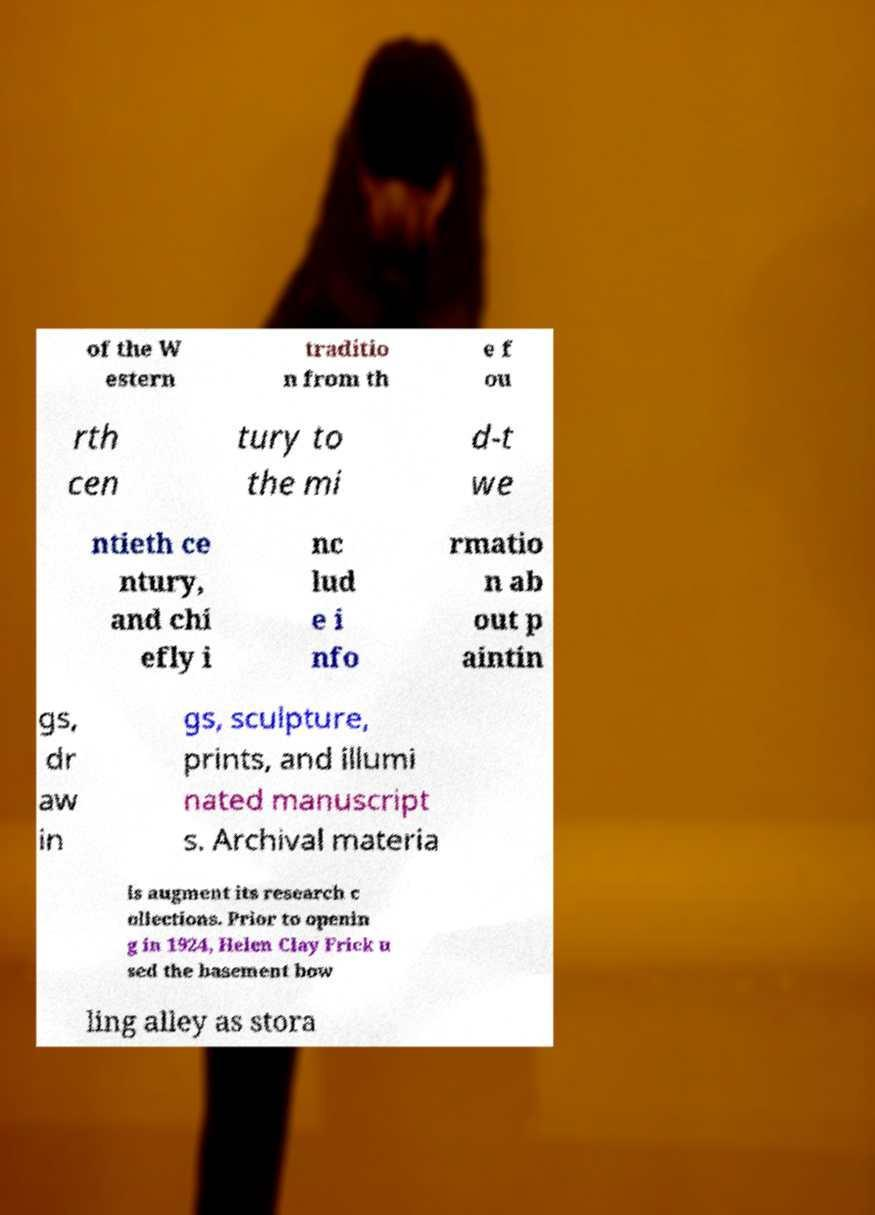There's text embedded in this image that I need extracted. Can you transcribe it verbatim? of the W estern traditio n from th e f ou rth cen tury to the mi d-t we ntieth ce ntury, and chi efly i nc lud e i nfo rmatio n ab out p aintin gs, dr aw in gs, sculpture, prints, and illumi nated manuscript s. Archival materia ls augment its research c ollections. Prior to openin g in 1924, Helen Clay Frick u sed the basement bow ling alley as stora 